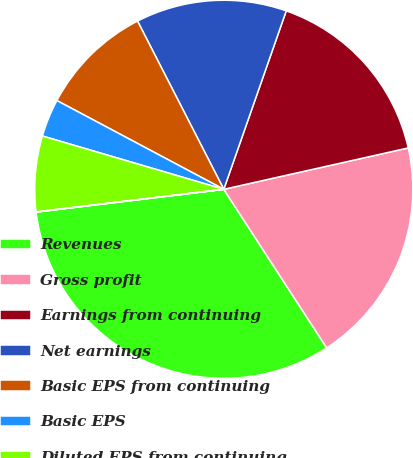Convert chart to OTSL. <chart><loc_0><loc_0><loc_500><loc_500><pie_chart><fcel>Revenues<fcel>Gross profit<fcel>Earnings from continuing<fcel>Net earnings<fcel>Basic EPS from continuing<fcel>Basic EPS<fcel>Diluted EPS from continuing<fcel>Diluted EPS<nl><fcel>32.24%<fcel>19.35%<fcel>16.13%<fcel>12.9%<fcel>9.68%<fcel>3.23%<fcel>6.46%<fcel>0.01%<nl></chart> 